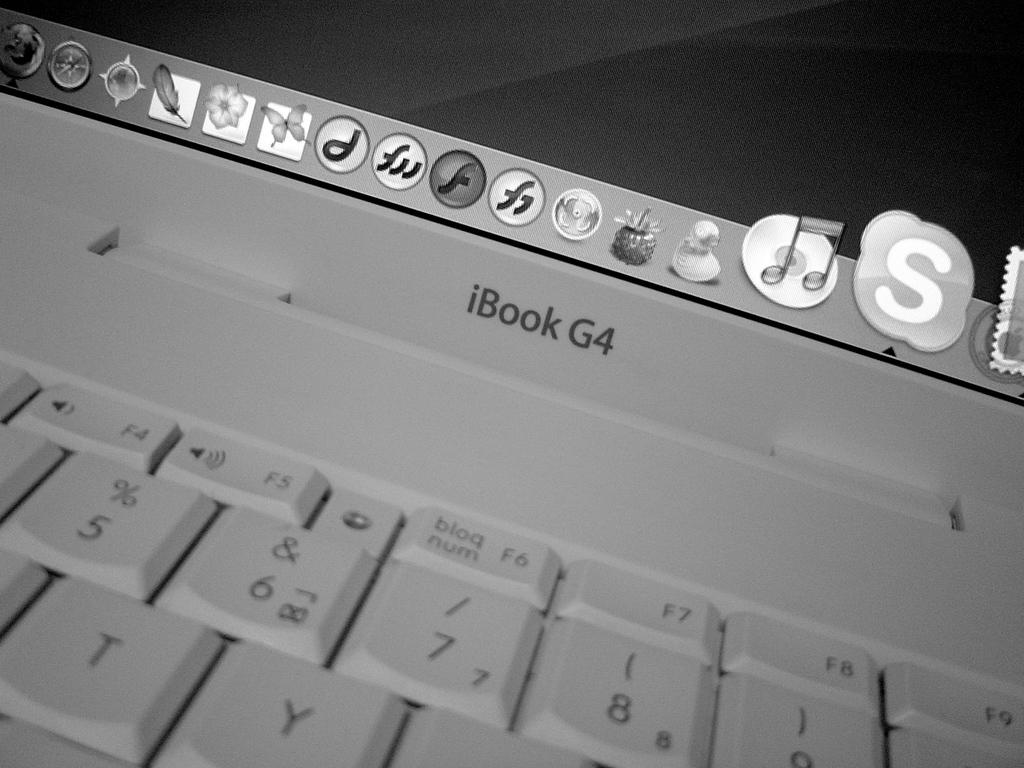<image>
Describe the image concisely. A white keyboard from iBook G4 with showing icons at the top of the keyboard. 